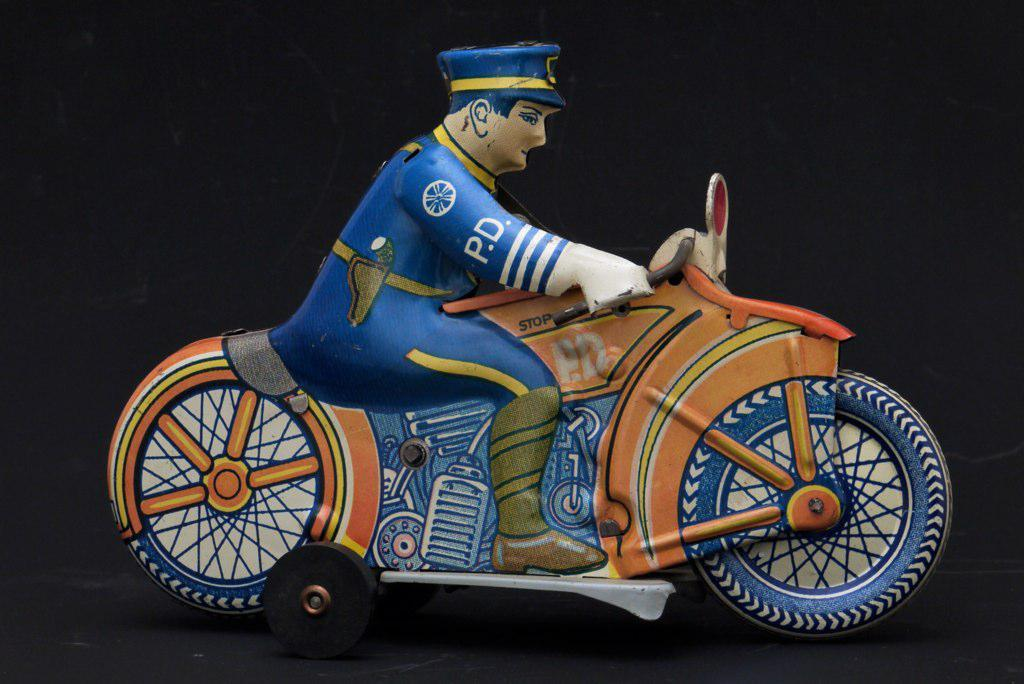What is the main subject in the middle of the image? There is a toy in the middle of the image. What can be observed about the background of the image? The background of the image is dark. What is the rate at which the bird is flying in the image? There is no bird present in the image, so it is not possible to determine the rate at which it might be flying. 